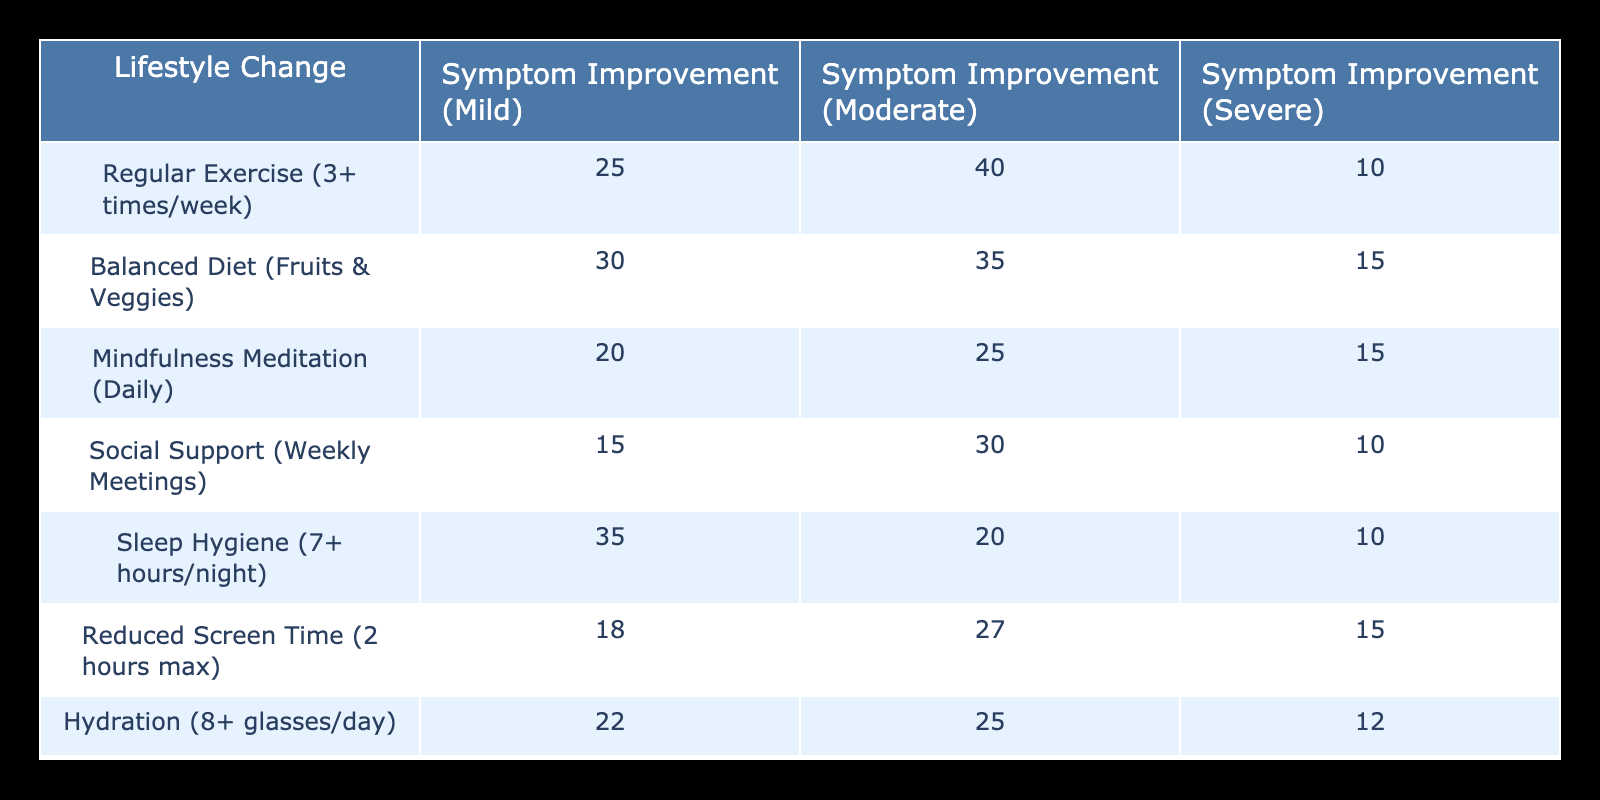What's the highest number of individuals reporting severe symptom improvement from any lifestyle change? By examining the table, the highest number for severe symptom improvement is from "Balanced Diet (Fruits & Veggies)" at 15 individuals.
Answer: 15 Which lifestyle change resulted in the least amount of mild symptom improvement? "Social Support (Weekly Meetings)" shows the least mild symptom improvement at 15 individuals compared to others such as sleep hygiene and smoking cessation.
Answer: 15 What is the overall count of individuals reporting any symptom improvement for "Mindfulness Meditation (Daily)"? Summing the values across all symptom improvement categories for this lifestyle change: 20 (mild) + 25 (moderate) + 15 (severe) = 60.
Answer: 60 Is it true that "Smoking Cessation" had more individuals benefiting from mild symptom improvement than "Regular Exercise"? Checking the values, "Smoking Cessation" has 40 for mild improvement while "Regular Exercise" has 25. Therefore, the statement is true.
Answer: Yes Calculate the average number of individuals reporting moderate symptom improvement across all lifestyle changes. First, we sum the moderate symptom improvement values: 40 + 35 + 25 + 30 + 20 + 27 + 25 + 30 =  232. Then, divide by the number of lifestyle changes (8): 232/8 = 29.
Answer: 29 Which lifestyle change saw the smallest difference between moderate and severe symptom improvement? The differences are: Regular Exercise (30), Balanced Diet (20), Mindfulness Meditation (10), Social Support (20), Sleep Hygiene (10), Reduced Screen Time (12), Hydration (13), Smoking Cessation (25). The smallest difference is 10 for both "Mindfulness Meditation" and "Sleep Hygiene."
Answer: Mindfulness Meditation, Sleep Hygiene Does "Hydration (8+ glasses/day)" have more individuals reporting moderate than severe symptom improvement? Looking at the table, "Hydration" shows 25 for moderate and 12 for severe. Since 25 > 12, the statement is true.
Answer: Yes What is the total count of individuals reporting mild symptom improvement across all lifestyle changes? Adding up the mild symptom improvement values: 25 + 30 + 20 + 15 + 35 + 18 + 22 + 40 = 195.
Answer: 195 